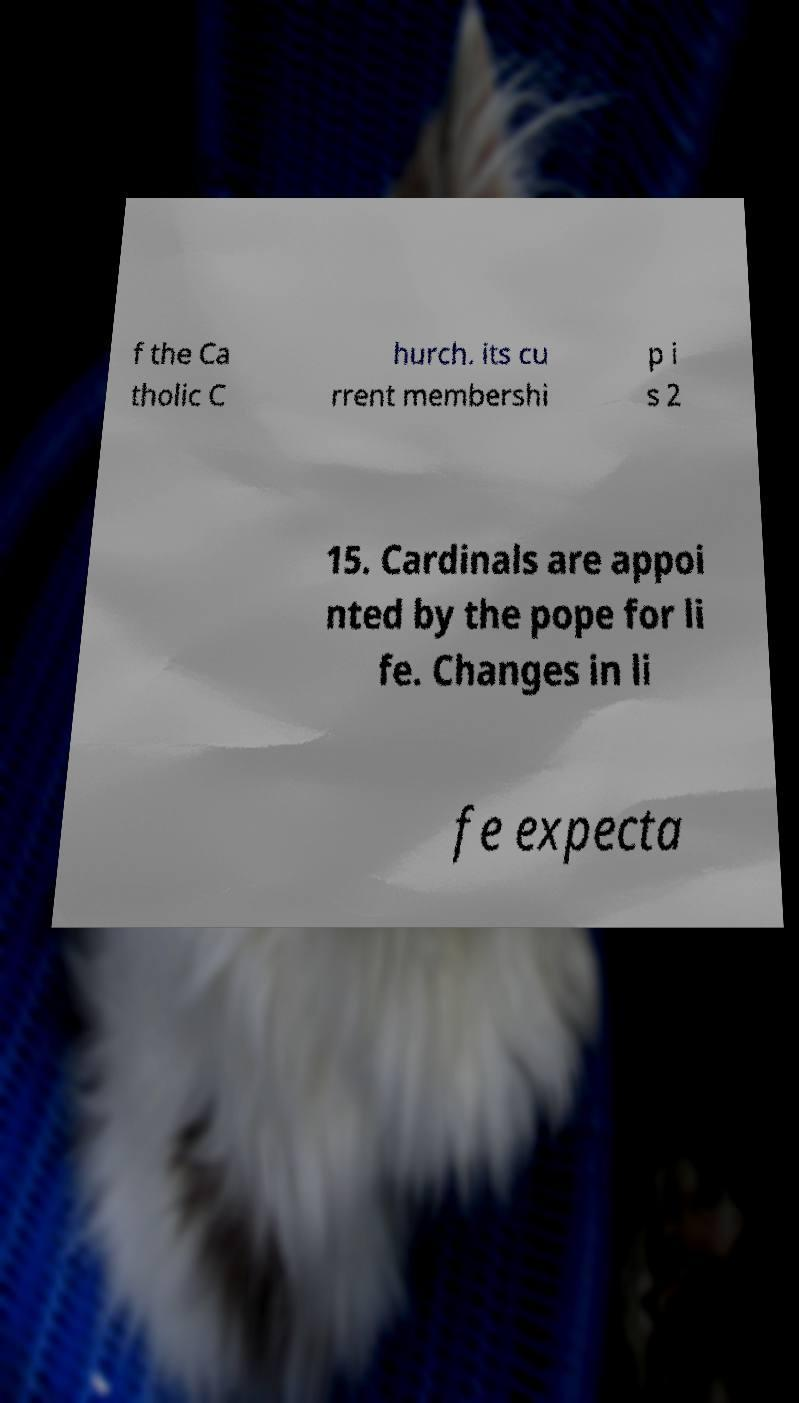I need the written content from this picture converted into text. Can you do that? f the Ca tholic C hurch. its cu rrent membershi p i s 2 15. Cardinals are appoi nted by the pope for li fe. Changes in li fe expecta 